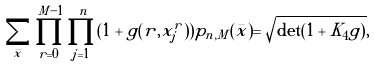Convert formula to latex. <formula><loc_0><loc_0><loc_500><loc_500>\sum _ { \bar { x } } \prod _ { r = 0 } ^ { M - 1 } \prod _ { j = 1 } ^ { n } ( 1 + g ( r , x _ { j } ^ { r } ) ) p _ { n , M } ( \bar { x } ) = \sqrt { \det ( 1 + K _ { 4 } g ) } ,</formula> 